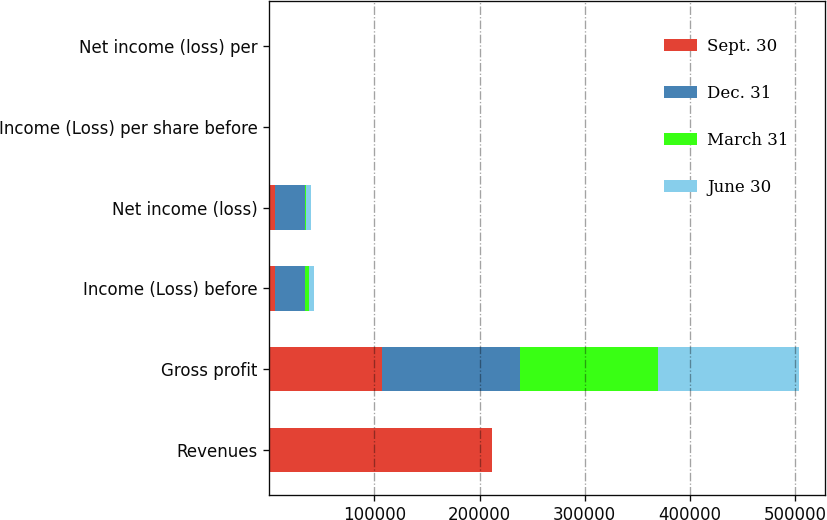Convert chart to OTSL. <chart><loc_0><loc_0><loc_500><loc_500><stacked_bar_chart><ecel><fcel>Revenues<fcel>Gross profit<fcel>Income (Loss) before<fcel>Net income (loss)<fcel>Income (Loss) per share before<fcel>Net income (loss) per<nl><fcel>Sept. 30<fcel>212137<fcel>107679<fcel>5383<fcel>5383<fcel>0.04<fcel>0.07<nl><fcel>Dec. 31<fcel>0.34<fcel>130592<fcel>28245<fcel>28245<fcel>0.06<fcel>0.34<nl><fcel>March 31<fcel>0.34<fcel>131054<fcel>4599<fcel>1707<fcel>0.19<fcel>0.02<nl><fcel>June 30<fcel>0.34<fcel>134275<fcel>4096<fcel>4096<fcel>0.17<fcel>0.05<nl></chart> 